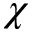Convert formula to latex. <formula><loc_0><loc_0><loc_500><loc_500>\chi</formula> 